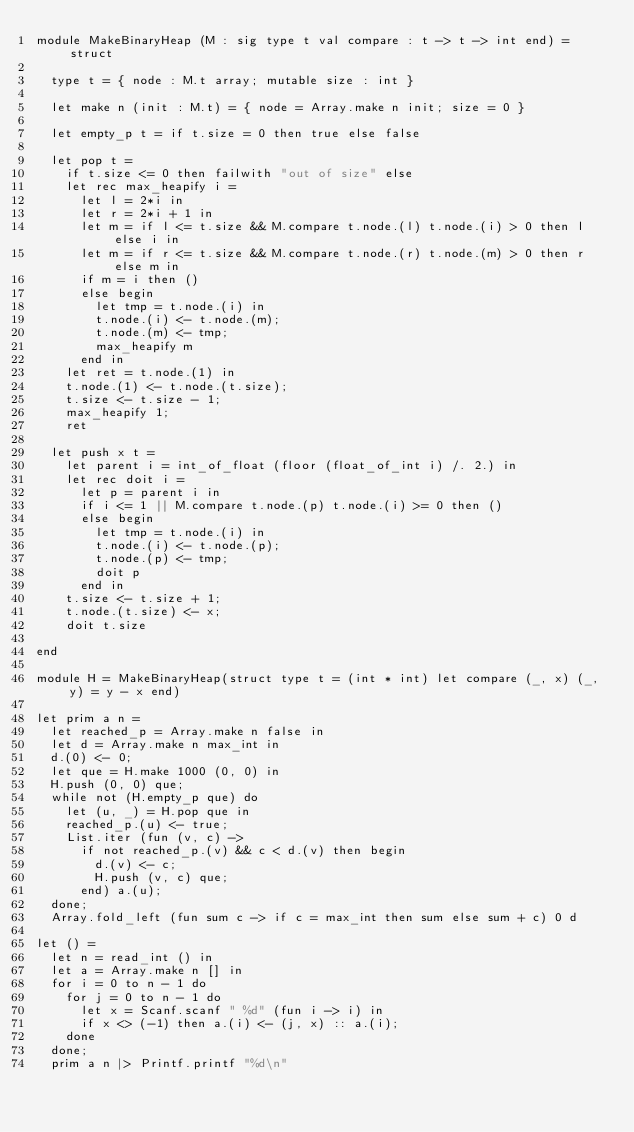Convert code to text. <code><loc_0><loc_0><loc_500><loc_500><_OCaml_>module MakeBinaryHeap (M : sig type t val compare : t -> t -> int end) = struct

  type t = { node : M.t array; mutable size : int }

  let make n (init : M.t) = { node = Array.make n init; size = 0 }

  let empty_p t = if t.size = 0 then true else false

  let pop t =
    if t.size <= 0 then failwith "out of size" else
    let rec max_heapify i =
      let l = 2*i in
      let r = 2*i + 1 in
      let m = if l <= t.size && M.compare t.node.(l) t.node.(i) > 0 then l else i in
      let m = if r <= t.size && M.compare t.node.(r) t.node.(m) > 0 then r else m in
      if m = i then ()
      else begin
        let tmp = t.node.(i) in
        t.node.(i) <- t.node.(m);
        t.node.(m) <- tmp;
        max_heapify m
      end in
    let ret = t.node.(1) in
    t.node.(1) <- t.node.(t.size);
    t.size <- t.size - 1;
    max_heapify 1;
    ret

  let push x t =
    let parent i = int_of_float (floor (float_of_int i) /. 2.) in
    let rec doit i =
      let p = parent i in
      if i <= 1 || M.compare t.node.(p) t.node.(i) >= 0 then ()
      else begin
        let tmp = t.node.(i) in
        t.node.(i) <- t.node.(p);
        t.node.(p) <- tmp;
        doit p
      end in
    t.size <- t.size + 1;
    t.node.(t.size) <- x;
    doit t.size

end

module H = MakeBinaryHeap(struct type t = (int * int) let compare (_, x) (_, y) = y - x end)

let prim a n =
  let reached_p = Array.make n false in
  let d = Array.make n max_int in
  d.(0) <- 0;
  let que = H.make 1000 (0, 0) in
  H.push (0, 0) que;
  while not (H.empty_p que) do
    let (u, _) = H.pop que in
    reached_p.(u) <- true;
    List.iter (fun (v, c) ->
      if not reached_p.(v) && c < d.(v) then begin
        d.(v) <- c;
        H.push (v, c) que;
      end) a.(u);
  done;
  Array.fold_left (fun sum c -> if c = max_int then sum else sum + c) 0 d

let () =
  let n = read_int () in
  let a = Array.make n [] in
  for i = 0 to n - 1 do
    for j = 0 to n - 1 do
      let x = Scanf.scanf " %d" (fun i -> i) in
      if x <> (-1) then a.(i) <- (j, x) :: a.(i);
    done
  done;
  prim a n |> Printf.printf "%d\n"</code> 